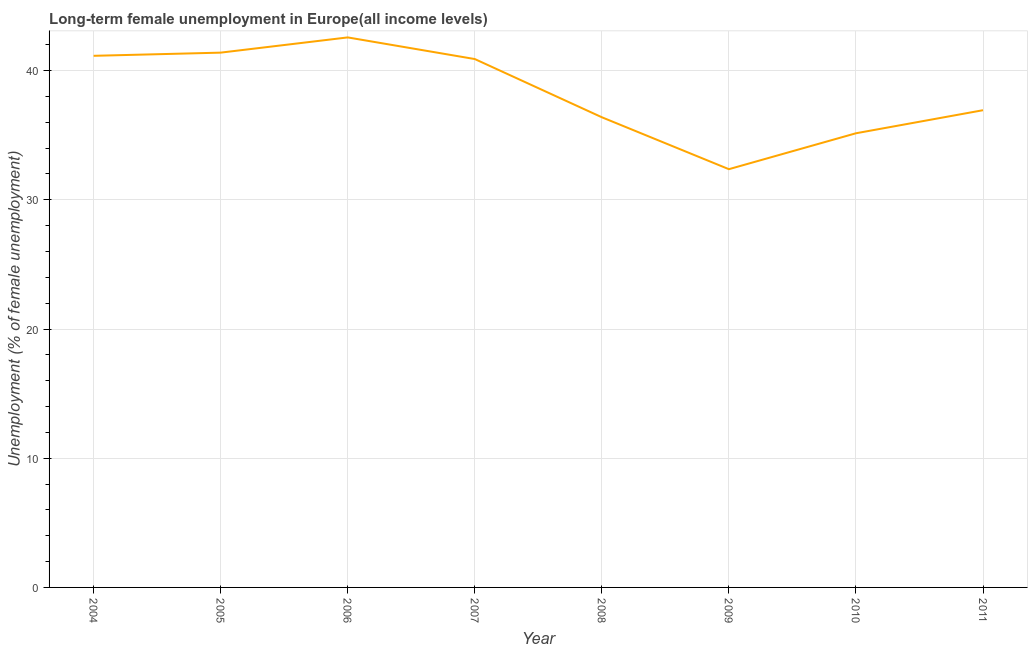What is the long-term female unemployment in 2010?
Offer a very short reply. 35.15. Across all years, what is the maximum long-term female unemployment?
Offer a terse response. 42.57. Across all years, what is the minimum long-term female unemployment?
Make the answer very short. 32.37. In which year was the long-term female unemployment maximum?
Make the answer very short. 2006. In which year was the long-term female unemployment minimum?
Your answer should be very brief. 2009. What is the sum of the long-term female unemployment?
Give a very brief answer. 306.85. What is the difference between the long-term female unemployment in 2004 and 2005?
Offer a terse response. -0.25. What is the average long-term female unemployment per year?
Make the answer very short. 38.36. What is the median long-term female unemployment?
Provide a succinct answer. 38.92. What is the ratio of the long-term female unemployment in 2007 to that in 2011?
Give a very brief answer. 1.11. Is the long-term female unemployment in 2006 less than that in 2010?
Your answer should be very brief. No. What is the difference between the highest and the second highest long-term female unemployment?
Your response must be concise. 1.18. Is the sum of the long-term female unemployment in 2004 and 2006 greater than the maximum long-term female unemployment across all years?
Your answer should be very brief. Yes. What is the difference between the highest and the lowest long-term female unemployment?
Your response must be concise. 10.2. In how many years, is the long-term female unemployment greater than the average long-term female unemployment taken over all years?
Provide a succinct answer. 4. How many lines are there?
Provide a short and direct response. 1. Does the graph contain grids?
Keep it short and to the point. Yes. What is the title of the graph?
Provide a succinct answer. Long-term female unemployment in Europe(all income levels). What is the label or title of the X-axis?
Make the answer very short. Year. What is the label or title of the Y-axis?
Your answer should be very brief. Unemployment (% of female unemployment). What is the Unemployment (% of female unemployment) in 2004?
Make the answer very short. 41.15. What is the Unemployment (% of female unemployment) of 2005?
Offer a very short reply. 41.39. What is the Unemployment (% of female unemployment) of 2006?
Provide a succinct answer. 42.57. What is the Unemployment (% of female unemployment) of 2007?
Provide a succinct answer. 40.9. What is the Unemployment (% of female unemployment) of 2008?
Your response must be concise. 36.39. What is the Unemployment (% of female unemployment) of 2009?
Your answer should be compact. 32.37. What is the Unemployment (% of female unemployment) in 2010?
Offer a very short reply. 35.15. What is the Unemployment (% of female unemployment) in 2011?
Offer a terse response. 36.94. What is the difference between the Unemployment (% of female unemployment) in 2004 and 2005?
Ensure brevity in your answer.  -0.25. What is the difference between the Unemployment (% of female unemployment) in 2004 and 2006?
Give a very brief answer. -1.42. What is the difference between the Unemployment (% of female unemployment) in 2004 and 2007?
Keep it short and to the point. 0.25. What is the difference between the Unemployment (% of female unemployment) in 2004 and 2008?
Provide a short and direct response. 4.76. What is the difference between the Unemployment (% of female unemployment) in 2004 and 2009?
Ensure brevity in your answer.  8.77. What is the difference between the Unemployment (% of female unemployment) in 2004 and 2010?
Provide a succinct answer. 5.99. What is the difference between the Unemployment (% of female unemployment) in 2004 and 2011?
Make the answer very short. 4.21. What is the difference between the Unemployment (% of female unemployment) in 2005 and 2006?
Provide a succinct answer. -1.18. What is the difference between the Unemployment (% of female unemployment) in 2005 and 2007?
Give a very brief answer. 0.5. What is the difference between the Unemployment (% of female unemployment) in 2005 and 2008?
Provide a succinct answer. 5. What is the difference between the Unemployment (% of female unemployment) in 2005 and 2009?
Offer a terse response. 9.02. What is the difference between the Unemployment (% of female unemployment) in 2005 and 2010?
Offer a very short reply. 6.24. What is the difference between the Unemployment (% of female unemployment) in 2005 and 2011?
Make the answer very short. 4.46. What is the difference between the Unemployment (% of female unemployment) in 2006 and 2007?
Your answer should be compact. 1.67. What is the difference between the Unemployment (% of female unemployment) in 2006 and 2008?
Ensure brevity in your answer.  6.18. What is the difference between the Unemployment (% of female unemployment) in 2006 and 2009?
Ensure brevity in your answer.  10.2. What is the difference between the Unemployment (% of female unemployment) in 2006 and 2010?
Make the answer very short. 7.42. What is the difference between the Unemployment (% of female unemployment) in 2006 and 2011?
Offer a very short reply. 5.63. What is the difference between the Unemployment (% of female unemployment) in 2007 and 2008?
Your answer should be compact. 4.51. What is the difference between the Unemployment (% of female unemployment) in 2007 and 2009?
Give a very brief answer. 8.52. What is the difference between the Unemployment (% of female unemployment) in 2007 and 2010?
Offer a terse response. 5.74. What is the difference between the Unemployment (% of female unemployment) in 2007 and 2011?
Provide a short and direct response. 3.96. What is the difference between the Unemployment (% of female unemployment) in 2008 and 2009?
Ensure brevity in your answer.  4.02. What is the difference between the Unemployment (% of female unemployment) in 2008 and 2010?
Give a very brief answer. 1.24. What is the difference between the Unemployment (% of female unemployment) in 2008 and 2011?
Keep it short and to the point. -0.55. What is the difference between the Unemployment (% of female unemployment) in 2009 and 2010?
Make the answer very short. -2.78. What is the difference between the Unemployment (% of female unemployment) in 2009 and 2011?
Provide a short and direct response. -4.57. What is the difference between the Unemployment (% of female unemployment) in 2010 and 2011?
Ensure brevity in your answer.  -1.79. What is the ratio of the Unemployment (% of female unemployment) in 2004 to that in 2006?
Provide a succinct answer. 0.97. What is the ratio of the Unemployment (% of female unemployment) in 2004 to that in 2008?
Give a very brief answer. 1.13. What is the ratio of the Unemployment (% of female unemployment) in 2004 to that in 2009?
Give a very brief answer. 1.27. What is the ratio of the Unemployment (% of female unemployment) in 2004 to that in 2010?
Provide a short and direct response. 1.17. What is the ratio of the Unemployment (% of female unemployment) in 2004 to that in 2011?
Keep it short and to the point. 1.11. What is the ratio of the Unemployment (% of female unemployment) in 2005 to that in 2007?
Give a very brief answer. 1.01. What is the ratio of the Unemployment (% of female unemployment) in 2005 to that in 2008?
Your answer should be compact. 1.14. What is the ratio of the Unemployment (% of female unemployment) in 2005 to that in 2009?
Offer a very short reply. 1.28. What is the ratio of the Unemployment (% of female unemployment) in 2005 to that in 2010?
Give a very brief answer. 1.18. What is the ratio of the Unemployment (% of female unemployment) in 2005 to that in 2011?
Offer a very short reply. 1.12. What is the ratio of the Unemployment (% of female unemployment) in 2006 to that in 2007?
Make the answer very short. 1.04. What is the ratio of the Unemployment (% of female unemployment) in 2006 to that in 2008?
Keep it short and to the point. 1.17. What is the ratio of the Unemployment (% of female unemployment) in 2006 to that in 2009?
Your answer should be compact. 1.31. What is the ratio of the Unemployment (% of female unemployment) in 2006 to that in 2010?
Offer a very short reply. 1.21. What is the ratio of the Unemployment (% of female unemployment) in 2006 to that in 2011?
Ensure brevity in your answer.  1.15. What is the ratio of the Unemployment (% of female unemployment) in 2007 to that in 2008?
Your answer should be compact. 1.12. What is the ratio of the Unemployment (% of female unemployment) in 2007 to that in 2009?
Your answer should be very brief. 1.26. What is the ratio of the Unemployment (% of female unemployment) in 2007 to that in 2010?
Keep it short and to the point. 1.16. What is the ratio of the Unemployment (% of female unemployment) in 2007 to that in 2011?
Provide a succinct answer. 1.11. What is the ratio of the Unemployment (% of female unemployment) in 2008 to that in 2009?
Offer a terse response. 1.12. What is the ratio of the Unemployment (% of female unemployment) in 2008 to that in 2010?
Make the answer very short. 1.03. What is the ratio of the Unemployment (% of female unemployment) in 2009 to that in 2010?
Offer a very short reply. 0.92. What is the ratio of the Unemployment (% of female unemployment) in 2009 to that in 2011?
Ensure brevity in your answer.  0.88. What is the ratio of the Unemployment (% of female unemployment) in 2010 to that in 2011?
Offer a very short reply. 0.95. 